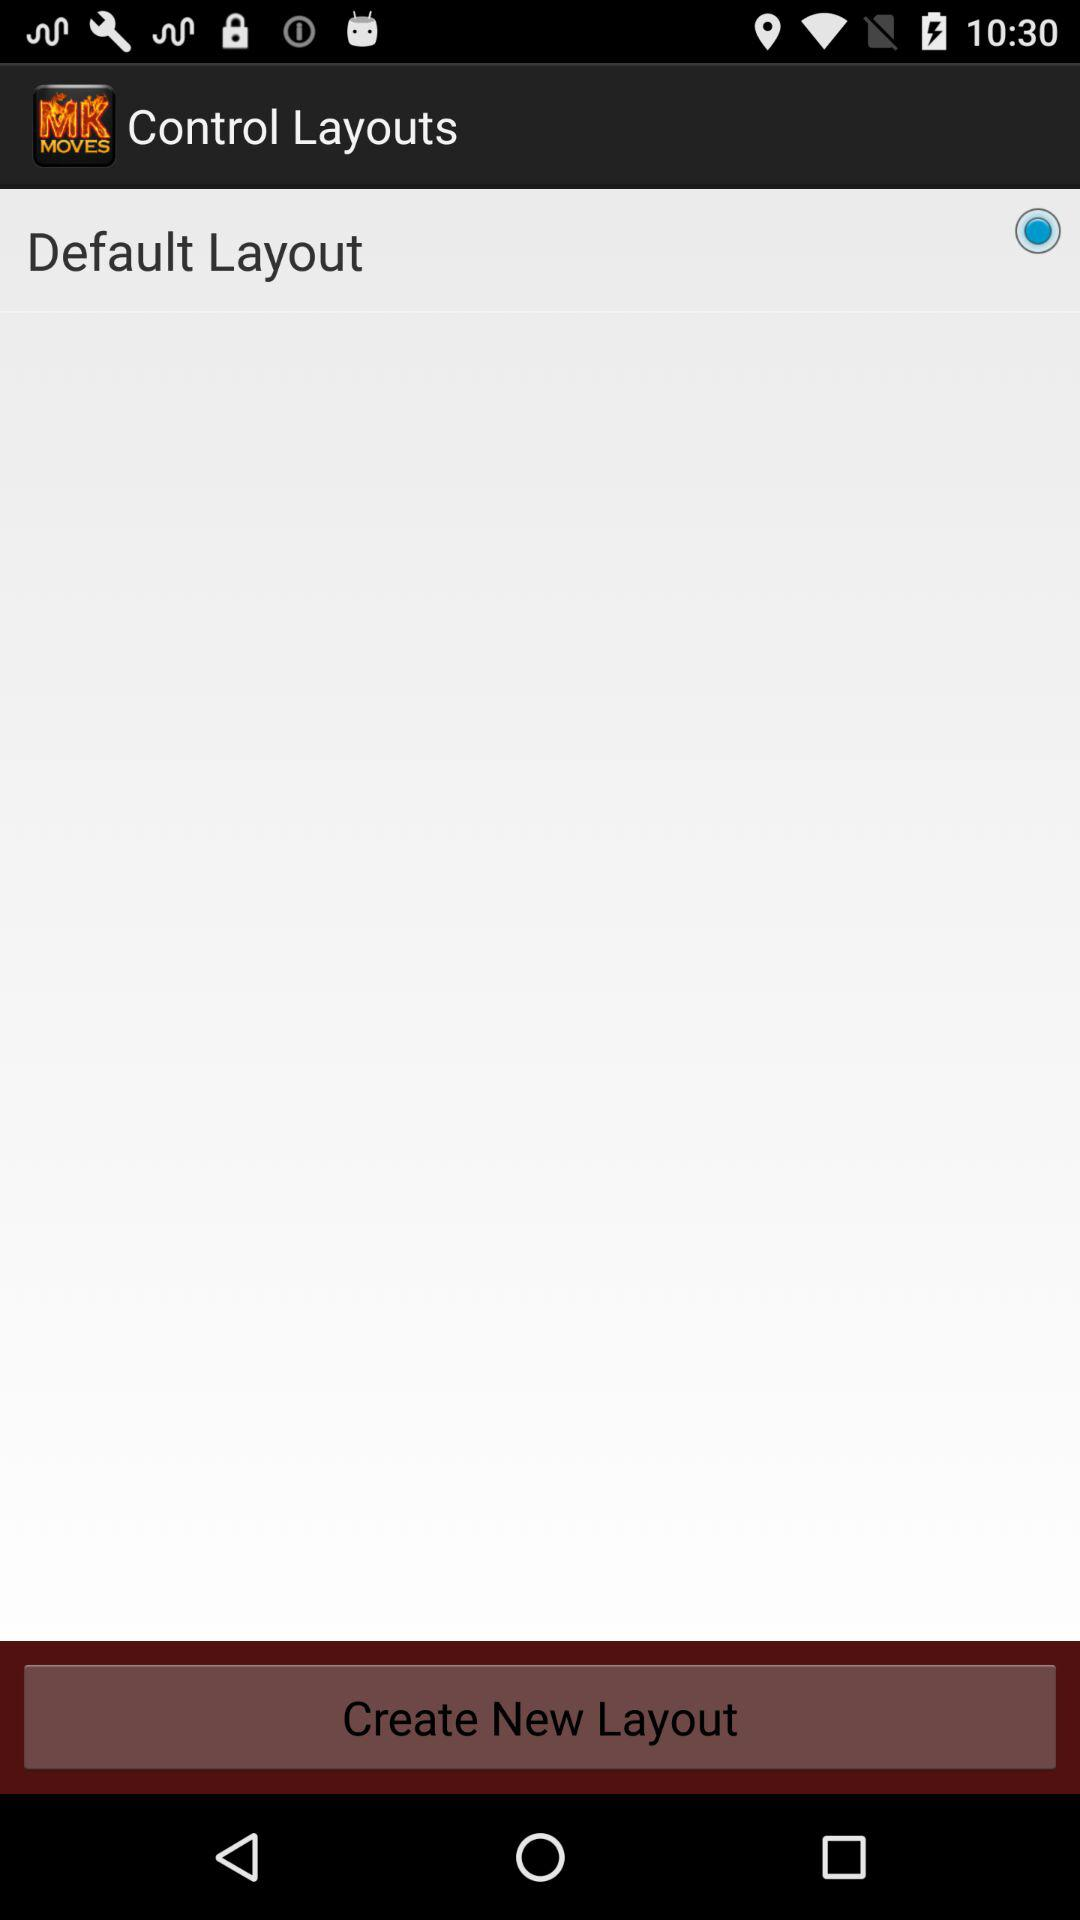What is the application name? The application name is "Moves for Mortal Kombat". 